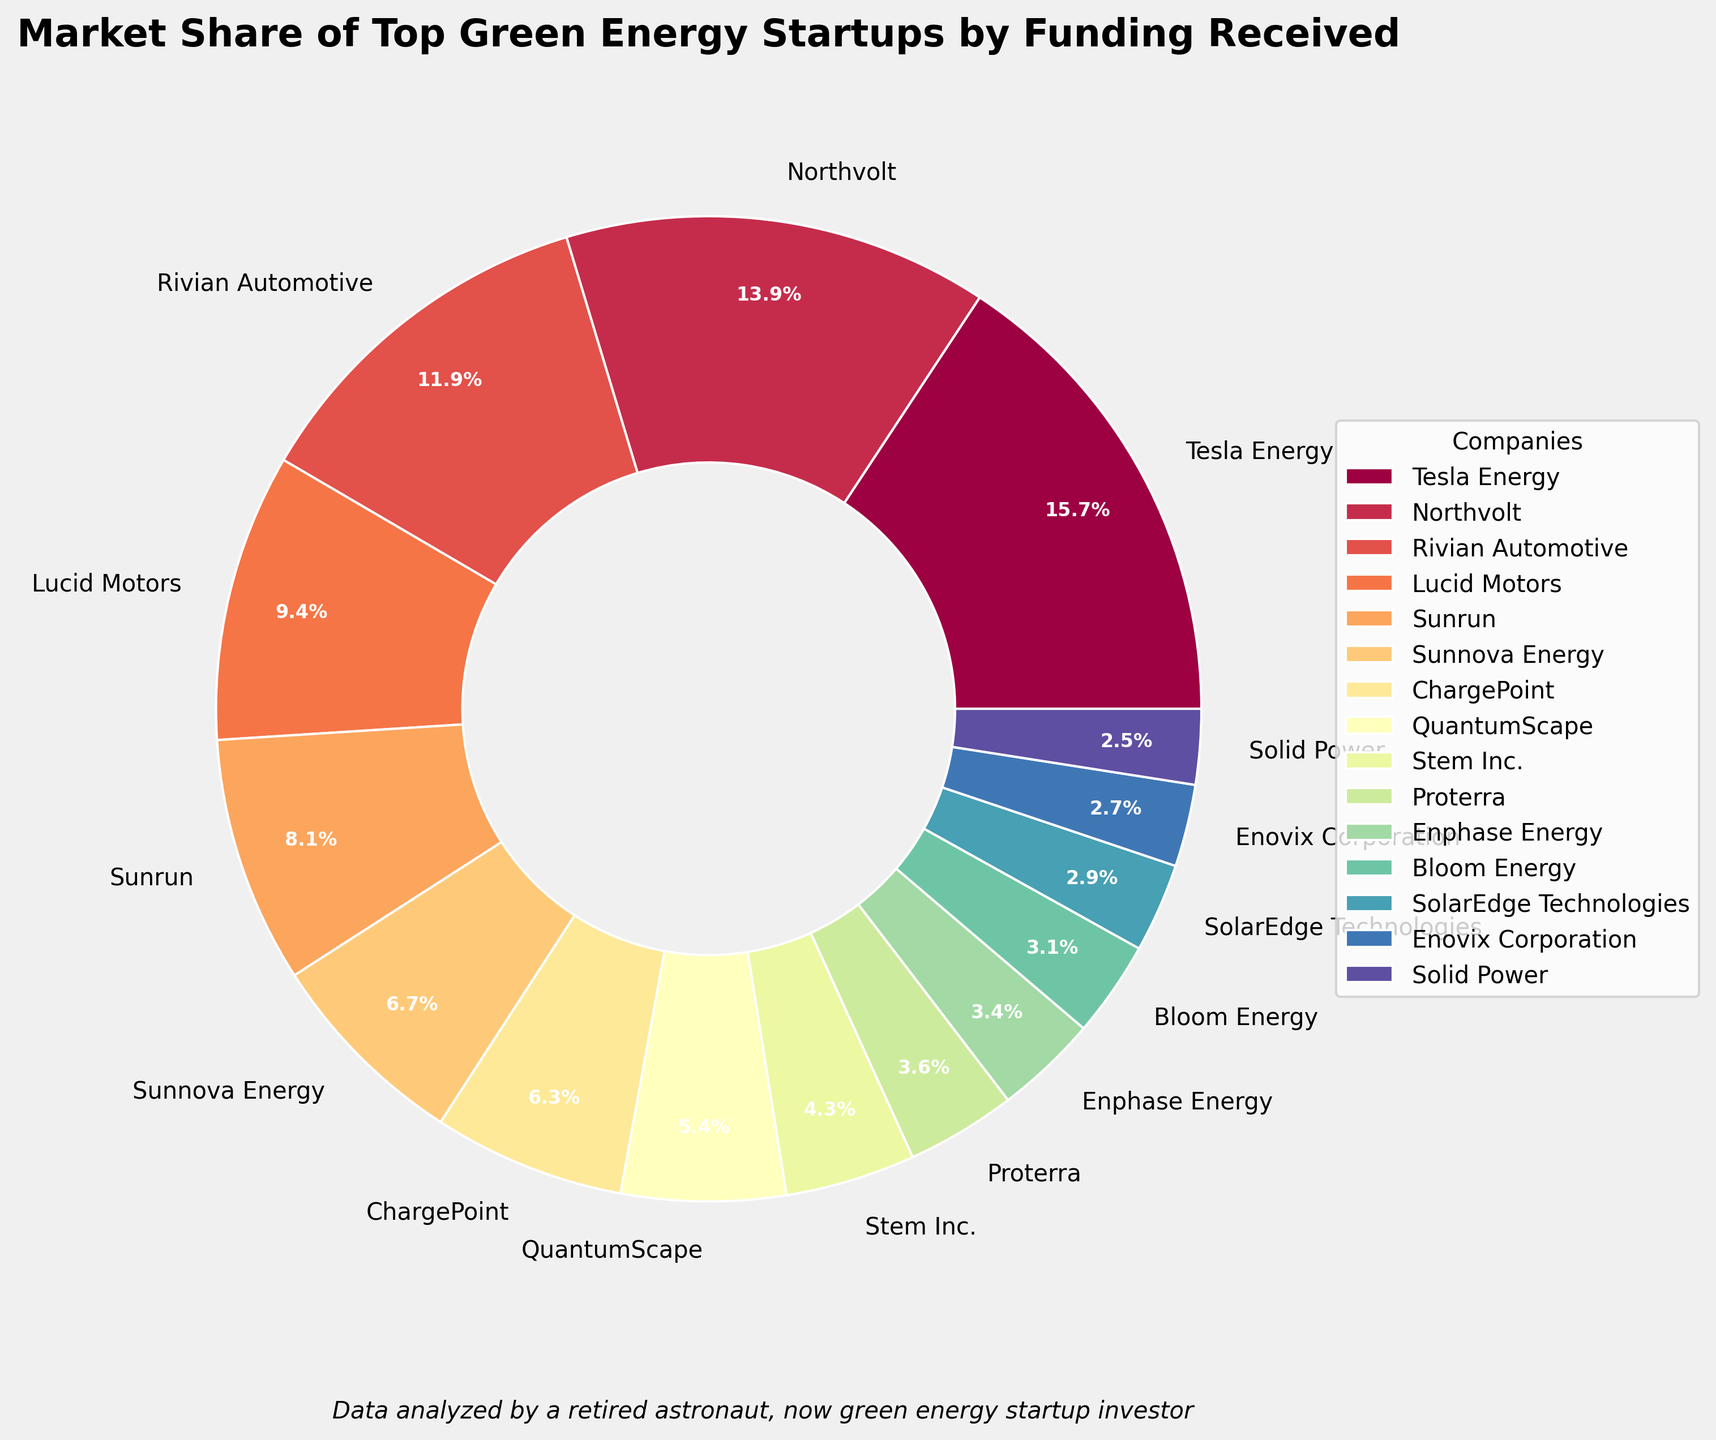How much funding have the top 3 green energy startups received in total? Sum the funding received by Tesla Energy, Northvolt, and Rivian Automotive: 3500 + 3100 + 2650 = 9250 million USD
Answer: 9250 million USD Which company has received more funding, Sunnova Energy or ChargePoint? Compare the funding amounts: Sunnova Energy (1500 million USD) and ChargePoint (1400 million USD). Sunnova Energy has received more.
Answer: Sunnova Energy Which companies have received less than 1000 million USD in funding? Identify companies with funding below 1000 based on the pie chart labels: Stem Inc., Proterra, Enphase Energy, Bloom Energy, SolarEdge Technologies, Enovix Corporation, Solid Power.
Answer: Stem Inc., Proterra, Enphase Energy, Bloom Energy, SolarEdge Technologies, Enovix Corporation, Solid Power What is the difference in funding received between Lucid Motors and Sunrun? Subtract the funding of Sunrun (1800 million USD) from Lucid Motors (2100 million USD): 2100 - 1800 = 300 million USD
Answer: 300 million USD What is the total funding received by the bottom 5 companies in the pie chart? Sum the funding received by Stem Inc. (950), Proterra (800), Enphase Energy (750), Bloom Energy (700), and SolarEdge Technologies (650): 950 + 800 + 750 + 700 + 650 = 3850 million USD
Answer: 3850 million USD How much more funding has QuantumScape received compared to Solid Power? Subtract the funding of Solid Power (550 million USD) from QuantumScape (1200 million USD): 1200 - 550 = 650 million USD
Answer: 650 million USD Which company has received the least amount of funding? Identify the company with the smallest slice in the pie chart: Solid Power (550 million USD).
Answer: Solid Power Do Tesla Energy and Northvolt together account for more than 50% of the total funding received by all companies? Calculate the combined funding of Tesla Energy and Northvolt: 3500 + 3100 = 6600 million USD. Compare it with the total funding of all companies by summing individual funding amounts and checking if 6600 represents more than half. Sum of all funding is 22950 million USD. Thus, 6600 / 22950 > 50%. It does account for more than 50%.
Answer: Yes How many companies have received over 2000 million USD in funding? Count the companies with funding greater than 2000 million USD: Tesla Energy, Northvolt, Rivian Automotive, Lucid Motors.
Answer: 4 